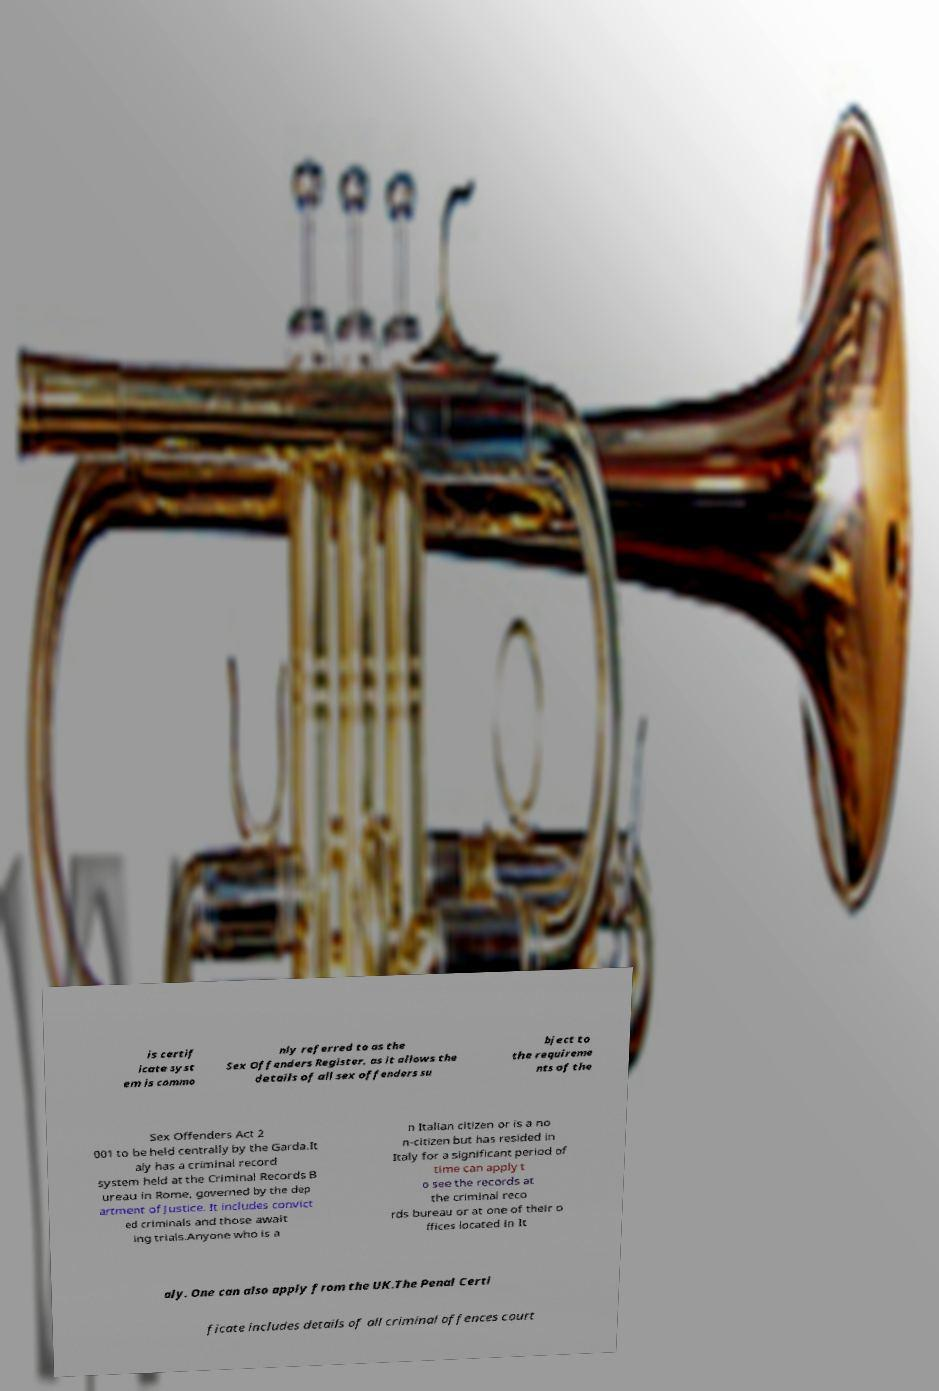Can you accurately transcribe the text from the provided image for me? is certif icate syst em is commo nly referred to as the Sex Offenders Register, as it allows the details of all sex offenders su bject to the requireme nts of the Sex Offenders Act 2 001 to be held centrally by the Garda.It aly has a criminal record system held at the Criminal Records B ureau in Rome, governed by the dep artment of Justice. It includes convict ed criminals and those await ing trials.Anyone who is a n Italian citizen or is a no n-citizen but has resided in Italy for a significant period of time can apply t o see the records at the criminal reco rds bureau or at one of their o ffices located in It aly. One can also apply from the UK.The Penal Certi ficate includes details of all criminal offences court 